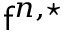Convert formula to latex. <formula><loc_0><loc_0><loc_500><loc_500>f ^ { n , ^ { * } }</formula> 